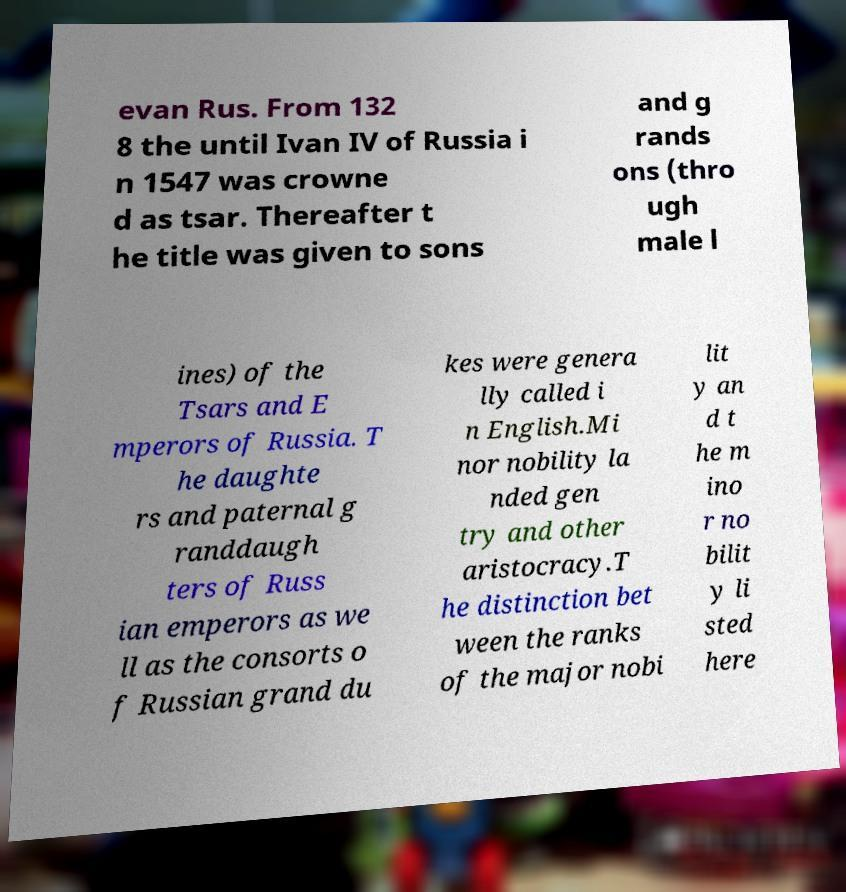Can you accurately transcribe the text from the provided image for me? evan Rus. From 132 8 the until Ivan IV of Russia i n 1547 was crowne d as tsar. Thereafter t he title was given to sons and g rands ons (thro ugh male l ines) of the Tsars and E mperors of Russia. T he daughte rs and paternal g randdaugh ters of Russ ian emperors as we ll as the consorts o f Russian grand du kes were genera lly called i n English.Mi nor nobility la nded gen try and other aristocracy.T he distinction bet ween the ranks of the major nobi lit y an d t he m ino r no bilit y li sted here 